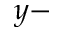Convert formula to latex. <formula><loc_0><loc_0><loc_500><loc_500>y -</formula> 